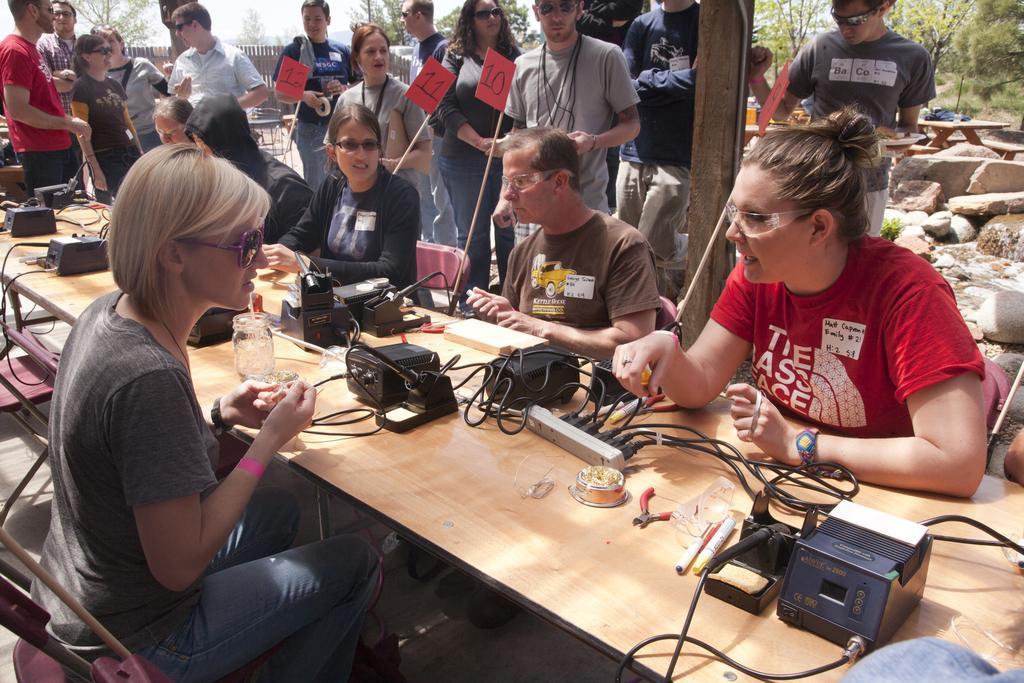Can you describe this image briefly? In this image there are a few people sitting in chairs, in front of them on the table there are some objects, behind them there are a few people standing, holding paper flags, behind them there are rocks, trees and there is a wooden fence. 